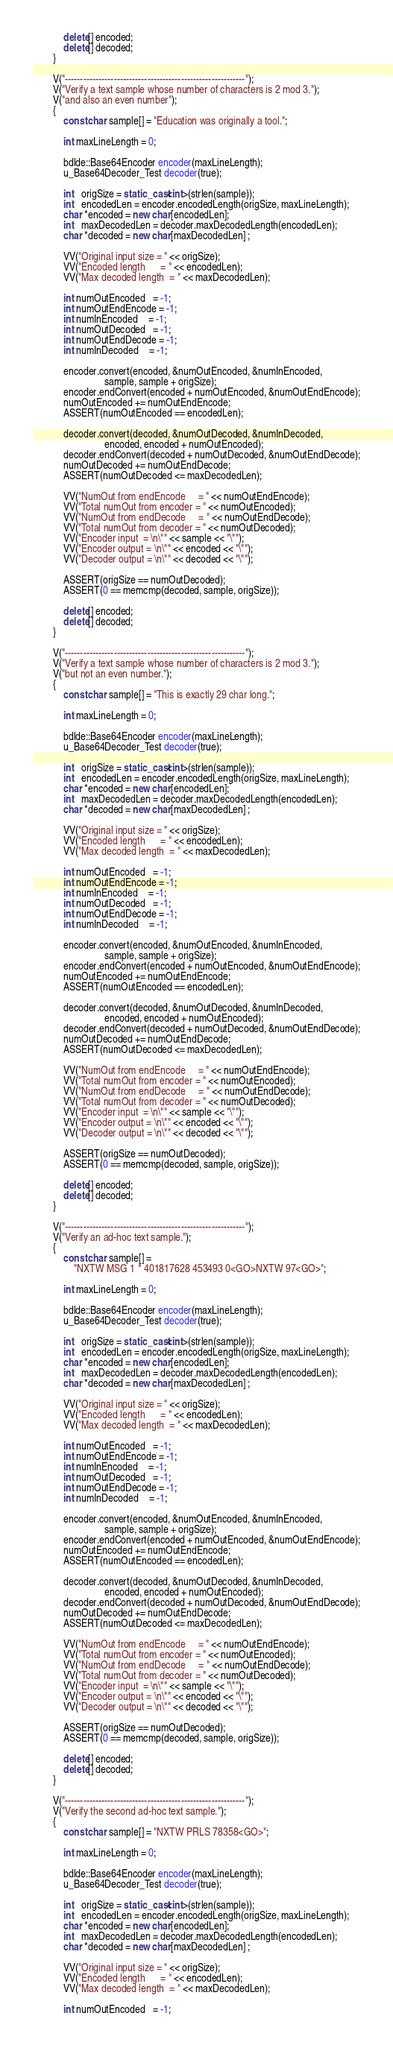<code> <loc_0><loc_0><loc_500><loc_500><_C++_>            delete[] encoded;
            delete[] decoded;
        }

        V("-----------------------------------------------------------");
        V("Verify a text sample whose number of characters is 2 mod 3.");
        V("and also an even number");
        {
            const char sample[] = "Education was originally a tool.";

            int maxLineLength = 0;

            bdlde::Base64Encoder encoder(maxLineLength);
            u_Base64Decoder_Test decoder(true);

            int   origSize = static_cast<int>(strlen(sample));
            int   encodedLen = encoder.encodedLength(origSize, maxLineLength);
            char *encoded = new char[encodedLen];
            int   maxDecodedLen = decoder.maxDecodedLength(encodedLen);
            char *decoded = new char[maxDecodedLen] ;

            VV("Original input size = " << origSize);
            VV("Encoded length      = " << encodedLen);
            VV("Max decoded length  = " << maxDecodedLen);

            int numOutEncoded   = -1;
            int numOutEndEncode = -1;
            int numInEncoded    = -1;
            int numOutDecoded   = -1;
            int numOutEndDecode = -1;
            int numInDecoded    = -1;

            encoder.convert(encoded, &numOutEncoded, &numInEncoded,
                            sample, sample + origSize);
            encoder.endConvert(encoded + numOutEncoded, &numOutEndEncode);
            numOutEncoded += numOutEndEncode;
            ASSERT(numOutEncoded == encodedLen);

            decoder.convert(decoded, &numOutDecoded, &numInDecoded,
                            encoded, encoded + numOutEncoded);
            decoder.endConvert(decoded + numOutDecoded, &numOutEndDecode);
            numOutDecoded += numOutEndDecode;
            ASSERT(numOutDecoded <= maxDecodedLen);

            VV("NumOut from endEncode     = " << numOutEndEncode);
            VV("Total numOut from encoder = " << numOutEncoded);
            VV("NumOut from endDecode     = " << numOutEndDecode);
            VV("Total numOut from decoder = " << numOutDecoded);
            VV("Encoder input  = \n\"" << sample << "\"");
            VV("Encoder output = \n\"" << encoded << "\"");
            VV("Decoder output = \n\"" << decoded << "\"");

            ASSERT(origSize == numOutDecoded);
            ASSERT(0 == memcmp(decoded, sample, origSize));

            delete[] encoded;
            delete[] decoded;
        }

        V("-----------------------------------------------------------");
        V("Verify a text sample whose number of characters is 2 mod 3.");
        V("but not an even number.");
        {
            const char sample[] = "This is exactly 29 char long.";

            int maxLineLength = 0;

            bdlde::Base64Encoder encoder(maxLineLength);
            u_Base64Decoder_Test decoder(true);

            int   origSize = static_cast<int>(strlen(sample));
            int   encodedLen = encoder.encodedLength(origSize, maxLineLength);
            char *encoded = new char[encodedLen];
            int   maxDecodedLen = decoder.maxDecodedLength(encodedLen);
            char *decoded = new char[maxDecodedLen] ;

            VV("Original input size = " << origSize);
            VV("Encoded length      = " << encodedLen);
            VV("Max decoded length  = " << maxDecodedLen);

            int numOutEncoded   = -1;
            int numOutEndEncode = -1;
            int numInEncoded    = -1;
            int numOutDecoded   = -1;
            int numOutEndDecode = -1;
            int numInDecoded    = -1;

            encoder.convert(encoded, &numOutEncoded, &numInEncoded,
                            sample, sample + origSize);
            encoder.endConvert(encoded + numOutEncoded, &numOutEndEncode);
            numOutEncoded += numOutEndEncode;
            ASSERT(numOutEncoded == encodedLen);

            decoder.convert(decoded, &numOutDecoded, &numInDecoded,
                            encoded, encoded + numOutEncoded);
            decoder.endConvert(decoded + numOutDecoded, &numOutEndDecode);
            numOutDecoded += numOutEndDecode;
            ASSERT(numOutDecoded <= maxDecodedLen);

            VV("NumOut from endEncode     = " << numOutEndEncode);
            VV("Total numOut from encoder = " << numOutEncoded);
            VV("NumOut from endDecode     = " << numOutEndDecode);
            VV("Total numOut from decoder = " << numOutDecoded);
            VV("Encoder input  = \n\"" << sample << "\"");
            VV("Encoder output = \n\"" << encoded << "\"");
            VV("Decoder output = \n\"" << decoded << "\"");

            ASSERT(origSize == numOutDecoded);
            ASSERT(0 == memcmp(decoded, sample, origSize));

            delete[] encoded;
            delete[] decoded;
        }

        V("-----------------------------------------------------------");
        V("Verify an ad-hoc text sample.");
        {
            const char sample[] =
                "NXTW MSG 1 * 401817628 453493 0<GO>NXTW 97<GO>";

            int maxLineLength = 0;

            bdlde::Base64Encoder encoder(maxLineLength);
            u_Base64Decoder_Test decoder(true);

            int   origSize = static_cast<int>(strlen(sample));
            int   encodedLen = encoder.encodedLength(origSize, maxLineLength);
            char *encoded = new char[encodedLen];
            int   maxDecodedLen = decoder.maxDecodedLength(encodedLen);
            char *decoded = new char[maxDecodedLen] ;

            VV("Original input size = " << origSize);
            VV("Encoded length      = " << encodedLen);
            VV("Max decoded length  = " << maxDecodedLen);

            int numOutEncoded   = -1;
            int numOutEndEncode = -1;
            int numInEncoded    = -1;
            int numOutDecoded   = -1;
            int numOutEndDecode = -1;
            int numInDecoded    = -1;

            encoder.convert(encoded, &numOutEncoded, &numInEncoded,
                            sample, sample + origSize);
            encoder.endConvert(encoded + numOutEncoded, &numOutEndEncode);
            numOutEncoded += numOutEndEncode;
            ASSERT(numOutEncoded == encodedLen);

            decoder.convert(decoded, &numOutDecoded, &numInDecoded,
                            encoded, encoded + numOutEncoded);
            decoder.endConvert(decoded + numOutDecoded, &numOutEndDecode);
            numOutDecoded += numOutEndDecode;
            ASSERT(numOutDecoded <= maxDecodedLen);

            VV("NumOut from endEncode     = " << numOutEndEncode);
            VV("Total numOut from encoder = " << numOutEncoded);
            VV("NumOut from endDecode     = " << numOutEndDecode);
            VV("Total numOut from decoder = " << numOutDecoded);
            VV("Encoder input  = \n\"" << sample << "\"");
            VV("Encoder output = \n\"" << encoded << "\"");
            VV("Decoder output = \n\"" << decoded << "\"");

            ASSERT(origSize == numOutDecoded);
            ASSERT(0 == memcmp(decoded, sample, origSize));

            delete[] encoded;
            delete[] decoded;
        }

        V("-----------------------------------------------------------");
        V("Verify the second ad-hoc text sample.");
        {
            const char sample[] = "NXTW PRLS 78358<GO>";

            int maxLineLength = 0;

            bdlde::Base64Encoder encoder(maxLineLength);
            u_Base64Decoder_Test decoder(true);

            int   origSize = static_cast<int>(strlen(sample));
            int   encodedLen = encoder.encodedLength(origSize, maxLineLength);
            char *encoded = new char[encodedLen];
            int   maxDecodedLen = decoder.maxDecodedLength(encodedLen);
            char *decoded = new char[maxDecodedLen] ;

            VV("Original input size = " << origSize);
            VV("Encoded length      = " << encodedLen);
            VV("Max decoded length  = " << maxDecodedLen);

            int numOutEncoded   = -1;</code> 